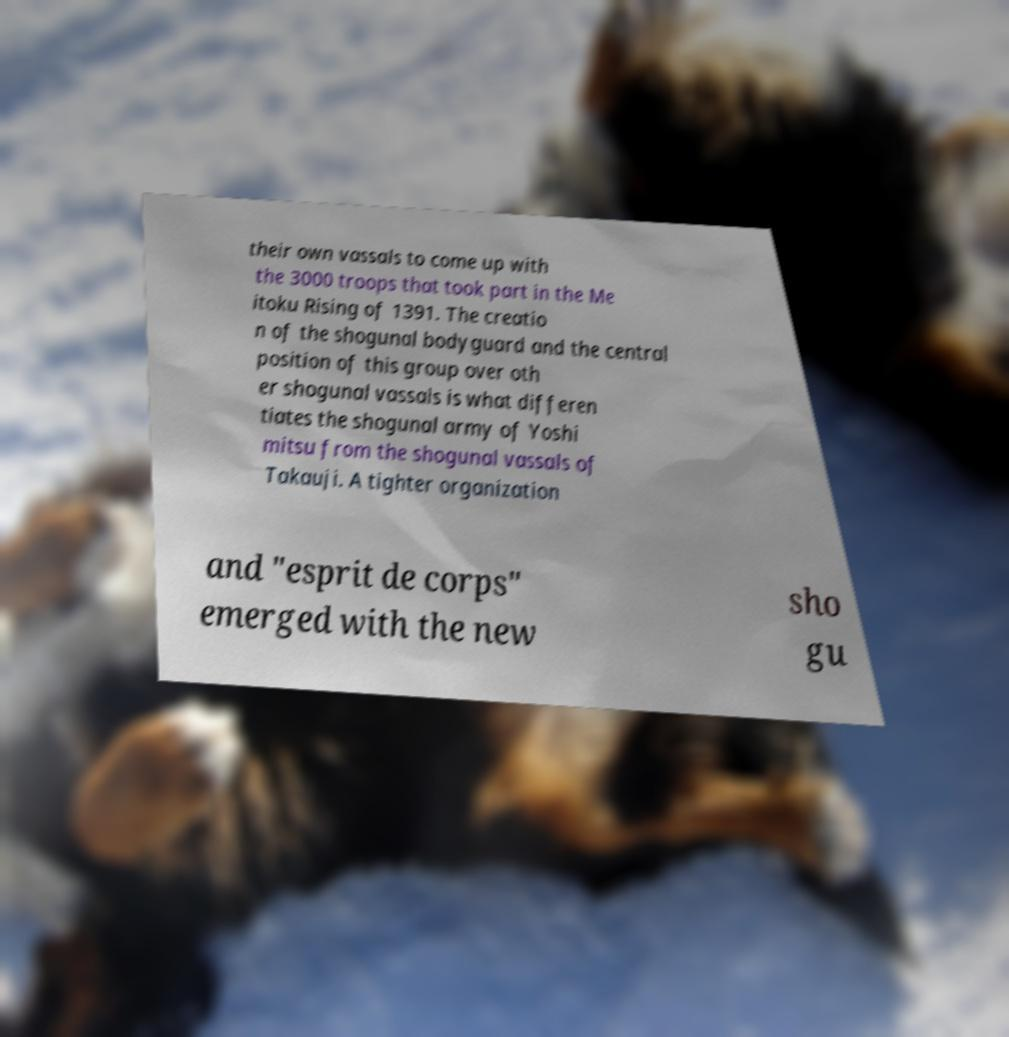Could you assist in decoding the text presented in this image and type it out clearly? their own vassals to come up with the 3000 troops that took part in the Me itoku Rising of 1391. The creatio n of the shogunal bodyguard and the central position of this group over oth er shogunal vassals is what differen tiates the shogunal army of Yoshi mitsu from the shogunal vassals of Takauji. A tighter organization and "esprit de corps" emerged with the new sho gu 